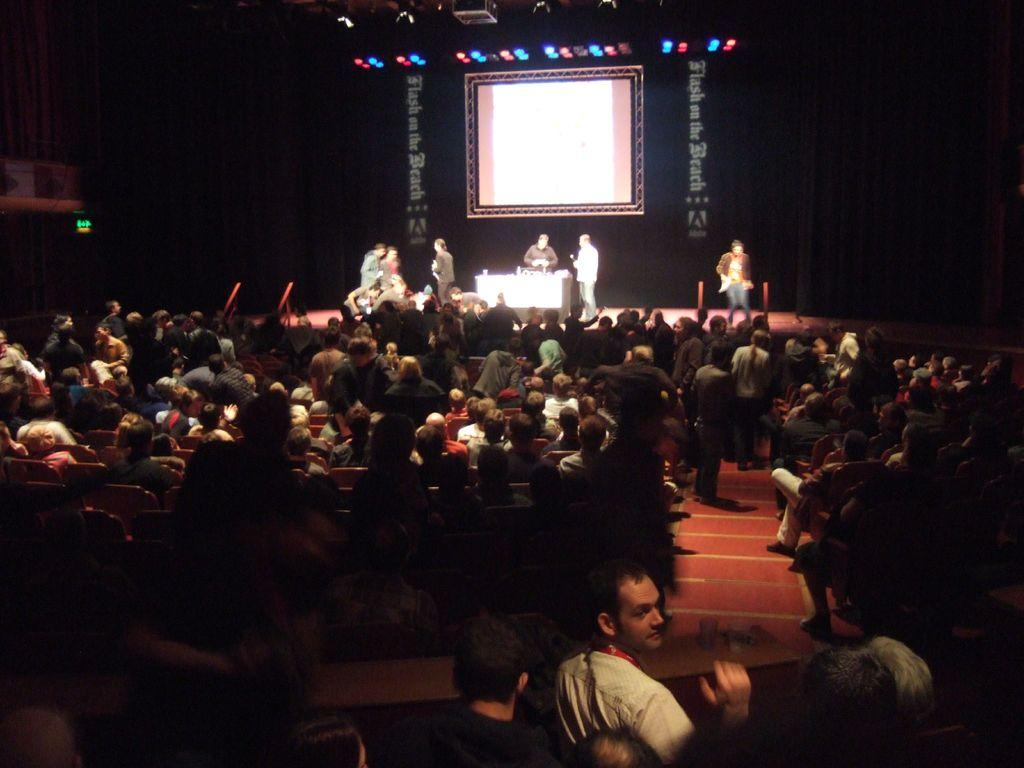What are the people in the image doing? The people in the image are sitting on chairs. Where are the people sitting in relation to the stage? These people are in front of a stage. What is happening on the stage? There are people on the stage. How would you describe the lighting in the image? The background of the image is dark. What type of instrument is being played by the people on the stage? There is no information about any instruments being played in the image. 